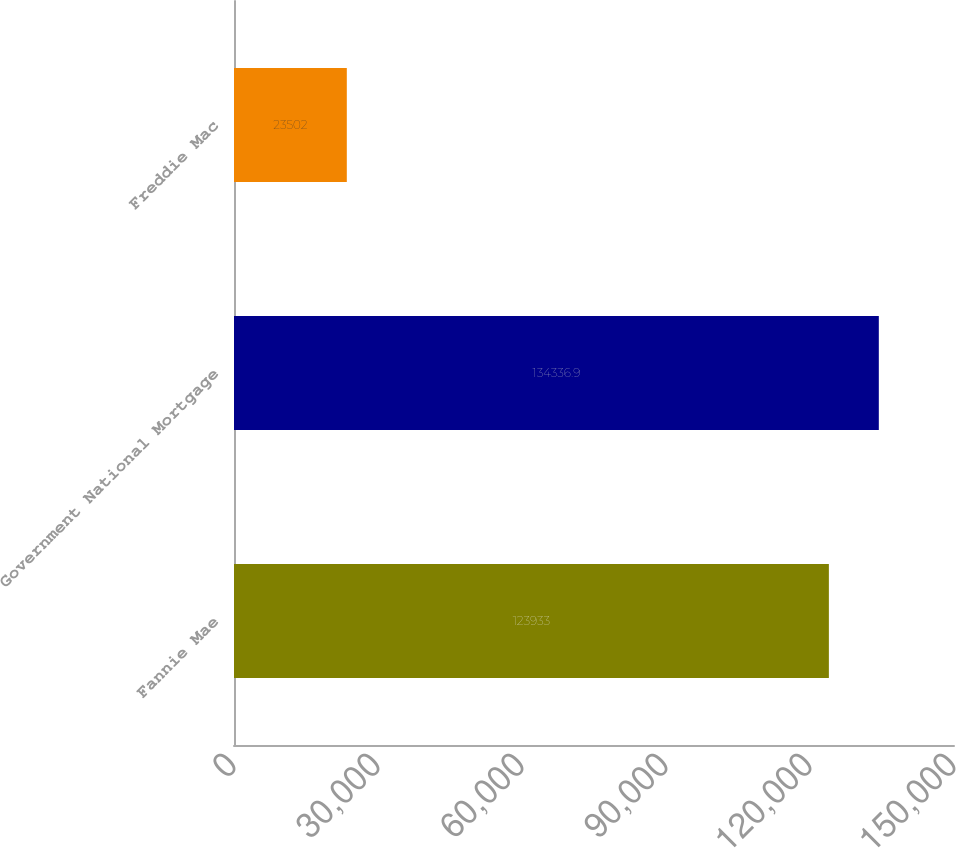Convert chart to OTSL. <chart><loc_0><loc_0><loc_500><loc_500><bar_chart><fcel>Fannie Mae<fcel>Government National Mortgage<fcel>Freddie Mac<nl><fcel>123933<fcel>134337<fcel>23502<nl></chart> 